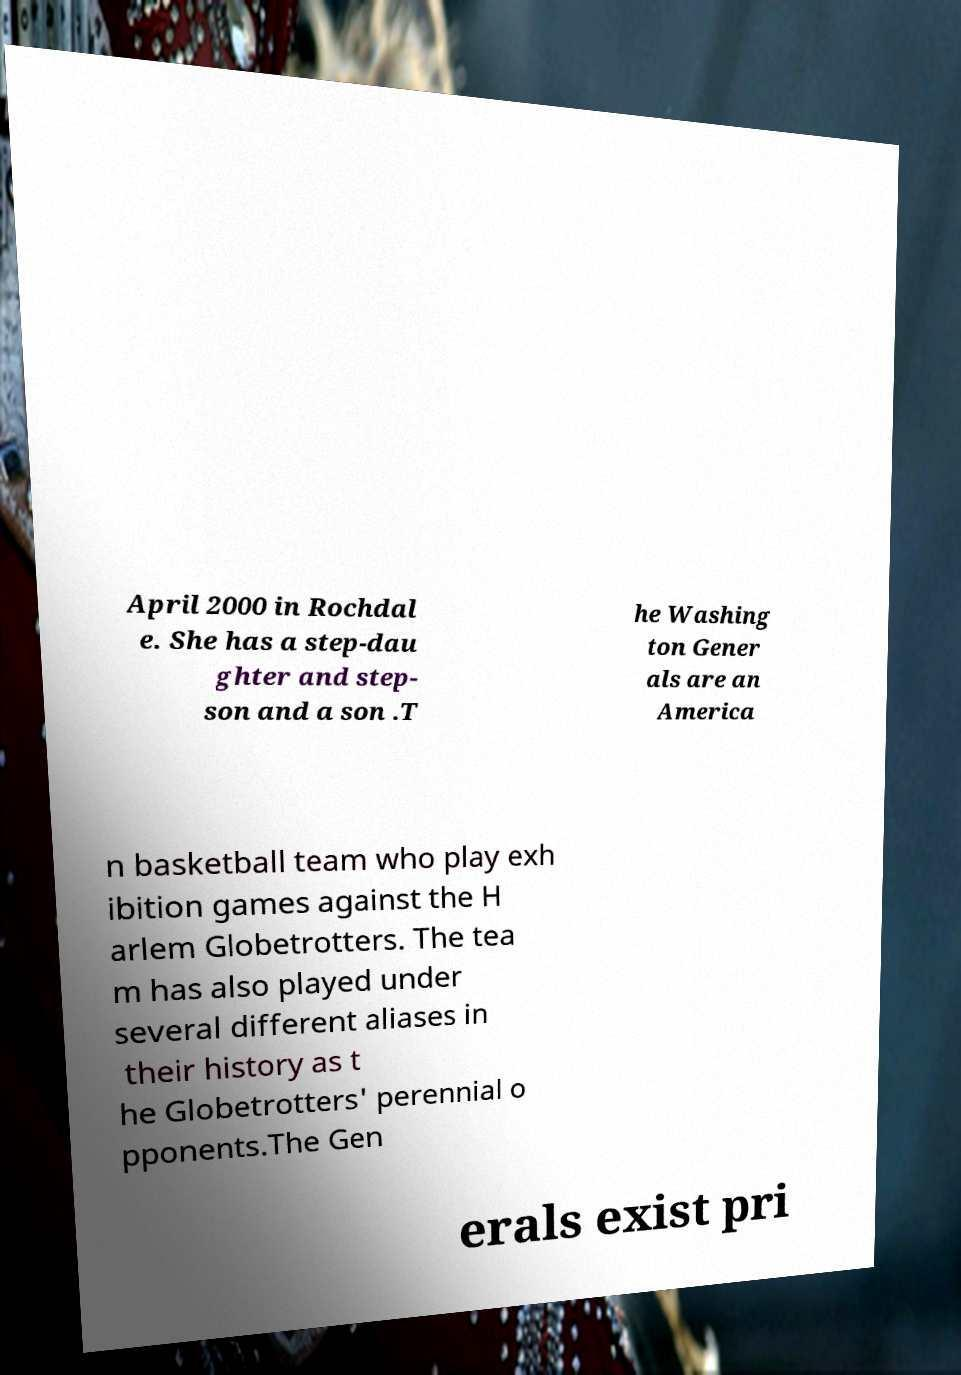What messages or text are displayed in this image? I need them in a readable, typed format. April 2000 in Rochdal e. She has a step-dau ghter and step- son and a son .T he Washing ton Gener als are an America n basketball team who play exh ibition games against the H arlem Globetrotters. The tea m has also played under several different aliases in their history as t he Globetrotters' perennial o pponents.The Gen erals exist pri 